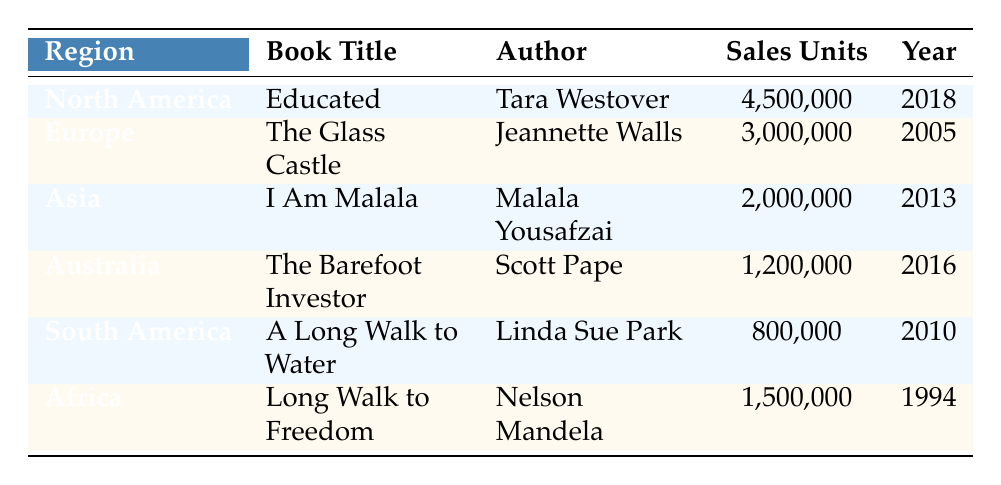What is the title of the memoir that sold the most units in North America? In the North America row of the table, the book listed is "Educated" by Tara Westover, which has the highest sales units of 4,500,000.
Answer: Educated Which author wrote "The Glass Castle"? The table lists "The Glass Castle" under the Europe region and states that it was written by Jeannette Walls.
Answer: Jeannette Walls How many sales units did "I Am Malala" achieve? The Asia row indicates that "I Am Malala" sold 2,000,000 units as noted next to the book title and author.
Answer: 2,000,000 Is "A Long Walk to Water" the least sold memoir in the table? To determine this, I look at the sales units for each book. "A Long Walk to Water" has 800,000 sales units, which is lower than all the other books listed. Hence, it is true.
Answer: Yes What is the total number of sales units for all memoirs listed in the table? To find the total, I sum the sales units: 4,500,000 (Educated) + 3,000,000 (The Glass Castle) + 2,000,000 (I Am Malala) + 1,200,000 (The Barefoot Investor) + 800,000 (A Long Walk to Water) + 1,500,000 (Long Walk to Freedom) = 12,000,000.
Answer: 12,000,000 Which memoir was published first, and how many sales units did it have? The only memoir listed from before the year 2000 is "Long Walk to Freedom," published in 1994. It sold 1,500,000 units.
Answer: Long Walk to Freedom, 1,500,000 Which region's memoir had the highest sales difference compared to South America? Comparing the sales units, North America has 4,500,000, while South America has 800,000. The difference is 4,500,000 - 800,000 = 3,700,000, which is the largest difference, making North America the region with the highest sales difference.
Answer: North America What is the average sales units for memoirs written after 2010? The memoirs after 2010 are "I Am Malala" (2,000,000 units), "The Barefoot Investor" (1,200,000 units), and "Educated" (4,500,000 units). The average is calculated as (2,000,000 + 1,200,000 + 4,500,000) / 3 = 2,566,667.
Answer: 2,566,667 What is the last memoir listed in the table, and what is its sales figure? The last memoir in the table by sorting the "Year" column is "A Long Walk to Water," published in 2010, with sales units of 800,000.
Answer: A Long Walk to Water, 800,000 